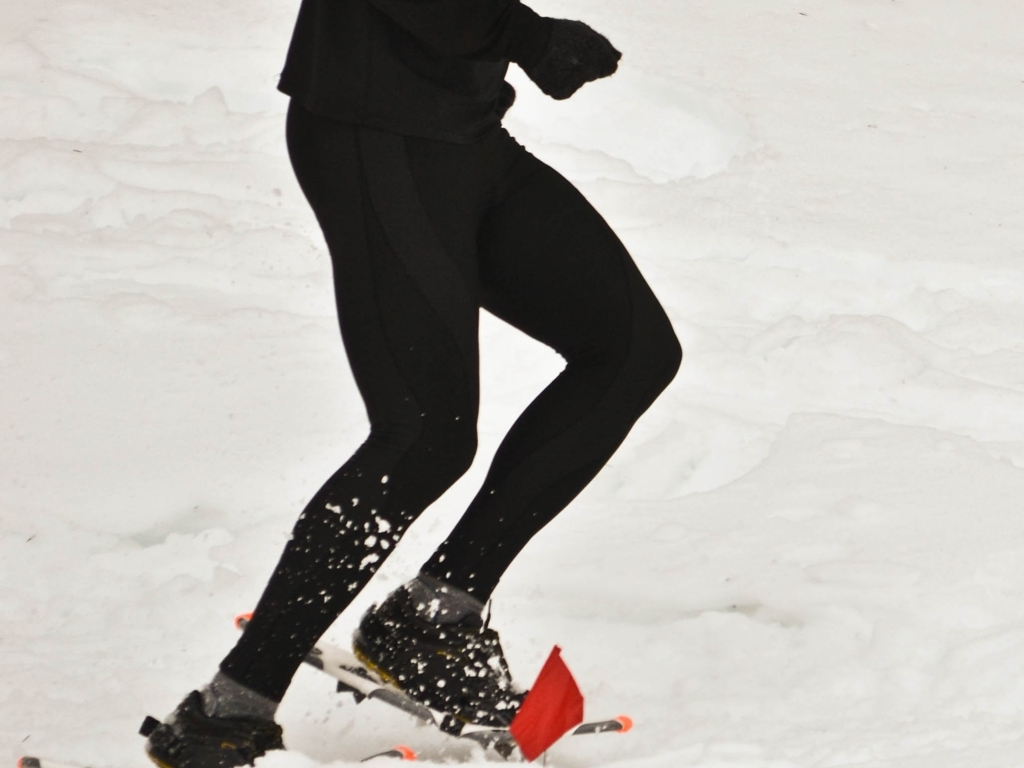Can you describe what the person in the image is doing? The person in the image appears to be running on a snowy surface. The stance and the position of the legs suggest that the individual is in the midst of a stride. Snow is being kicked up by the runner's shoes, indicating movement and the action of running. 